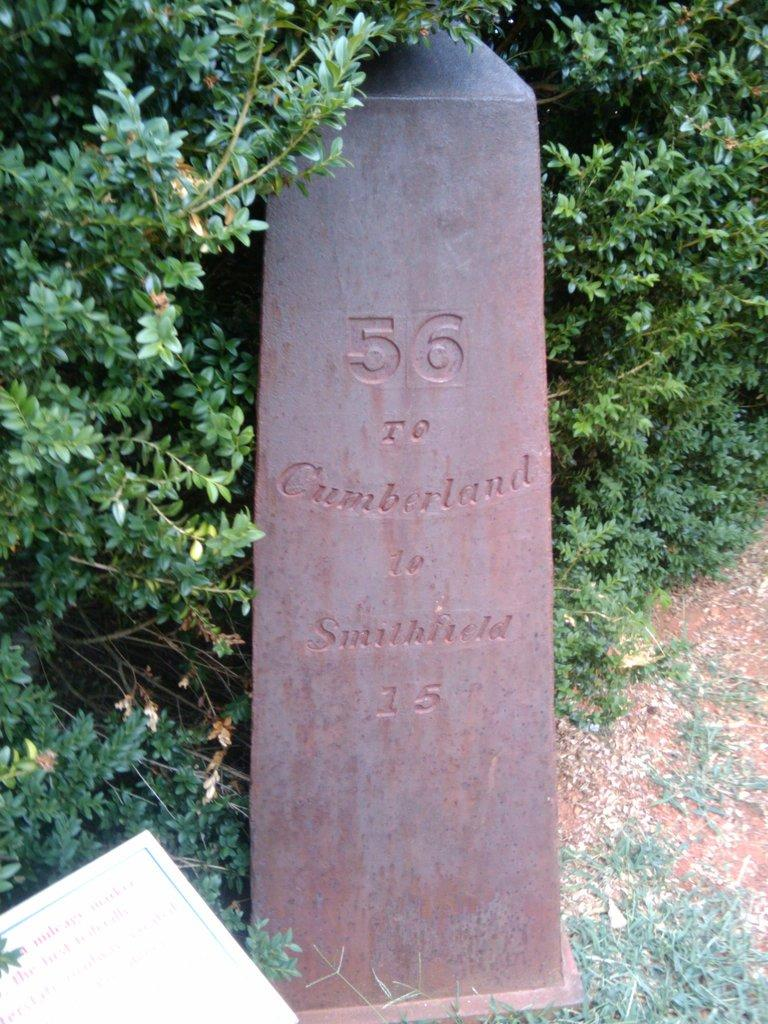What type of living organisms can be seen in the image? Plants can be seen in the image. What is the main structure located in the middle of the image? There is a monument stone in the middle of the image. Where is the board located in the image? The board is in the bottom left of the image. What advice is written on the monument stone in the image? There is no text or advice visible on the monument stone in the image. Can you see any waves in the image? There are no waves present in the image. 